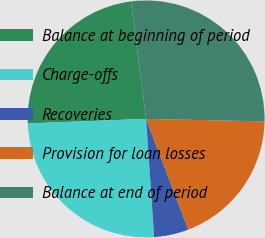<chart> <loc_0><loc_0><loc_500><loc_500><pie_chart><fcel>Balance at beginning of period<fcel>Charge-offs<fcel>Recoveries<fcel>Provision for loan losses<fcel>Balance at end of period<nl><fcel>23.58%<fcel>25.47%<fcel>4.72%<fcel>18.87%<fcel>27.36%<nl></chart> 